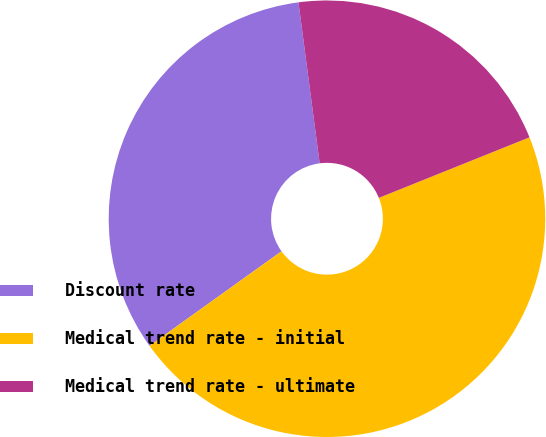<chart> <loc_0><loc_0><loc_500><loc_500><pie_chart><fcel>Discount rate<fcel>Medical trend rate - initial<fcel>Medical trend rate - ultimate<nl><fcel>32.81%<fcel>46.19%<fcel>21.0%<nl></chart> 